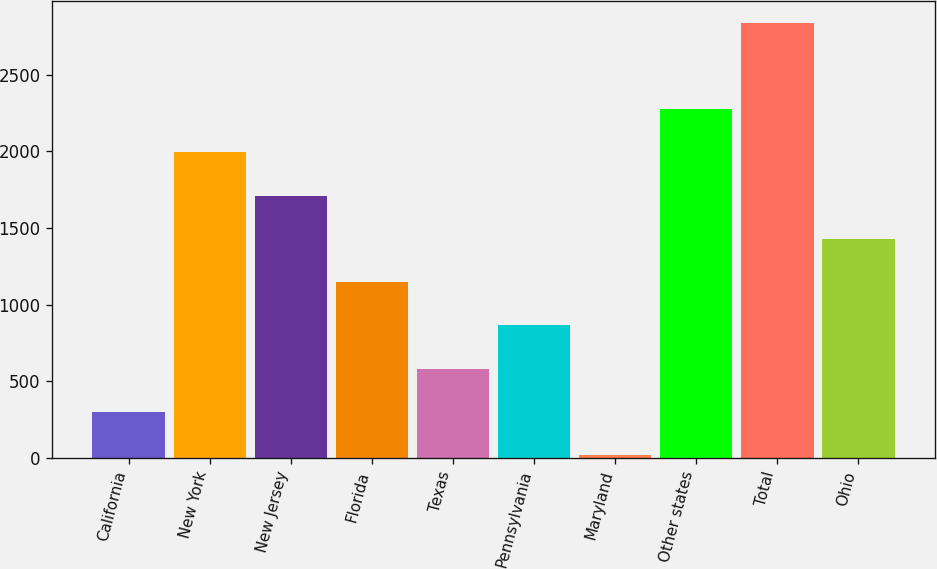Convert chart. <chart><loc_0><loc_0><loc_500><loc_500><bar_chart><fcel>California<fcel>New York<fcel>New Jersey<fcel>Florida<fcel>Texas<fcel>Pennsylvania<fcel>Maryland<fcel>Other states<fcel>Total<fcel>Ohio<nl><fcel>301.9<fcel>1993.3<fcel>1711.4<fcel>1147.6<fcel>583.8<fcel>865.7<fcel>20<fcel>2275.2<fcel>2839<fcel>1429.5<nl></chart> 